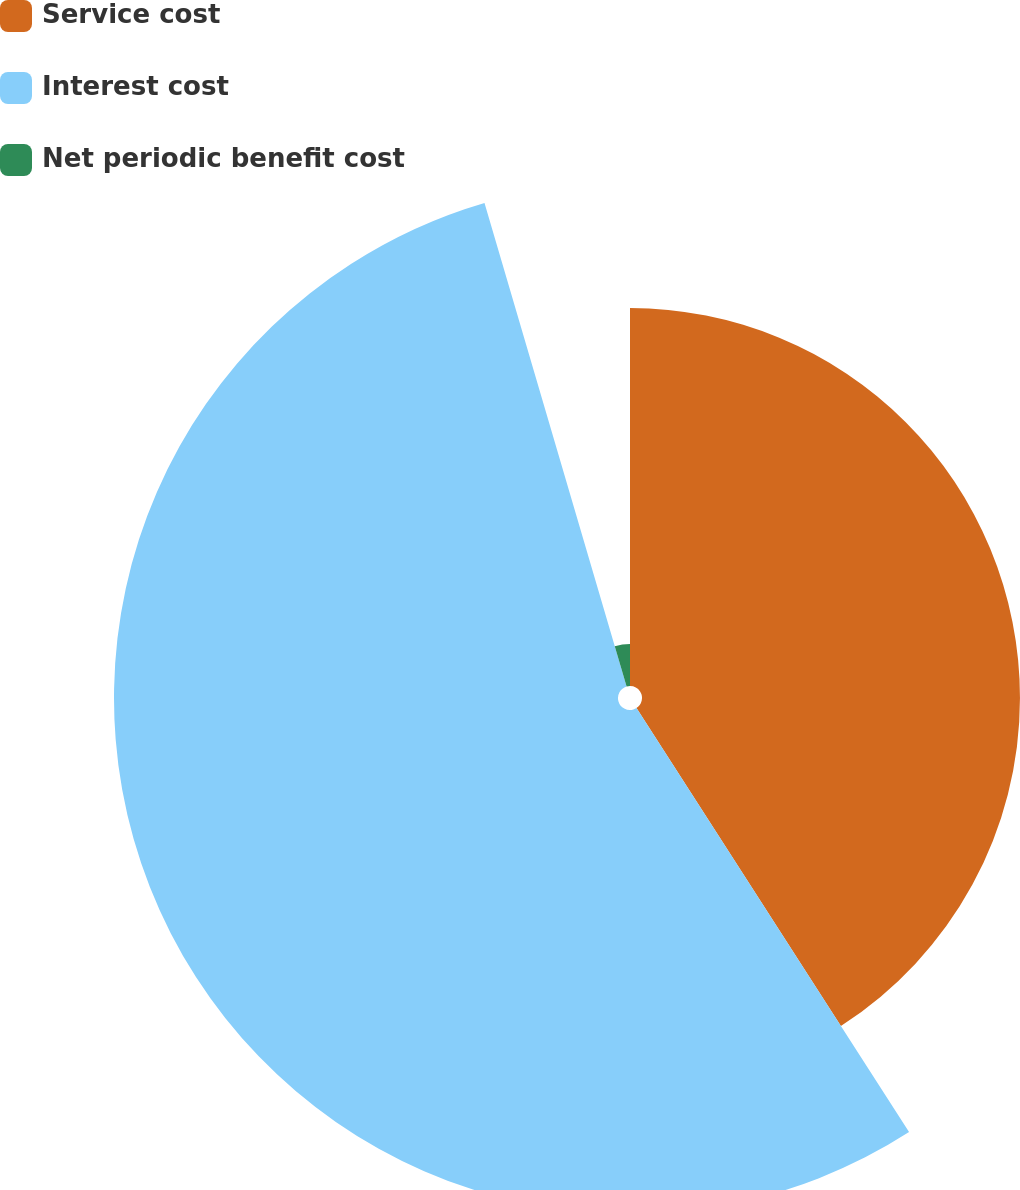<chart> <loc_0><loc_0><loc_500><loc_500><pie_chart><fcel>Service cost<fcel>Interest cost<fcel>Net periodic benefit cost<nl><fcel>40.91%<fcel>54.55%<fcel>4.55%<nl></chart> 